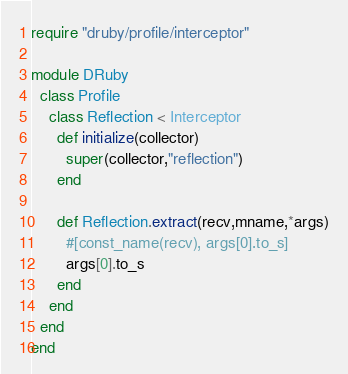<code> <loc_0><loc_0><loc_500><loc_500><_Ruby_>
require "druby/profile/interceptor"

module DRuby
  class Profile
    class Reflection < Interceptor
      def initialize(collector)
        super(collector,"reflection")
      end

      def Reflection.extract(recv,mname,*args)
        #[const_name(recv), args[0].to_s]
        args[0].to_s
      end
    end
  end
end

</code> 